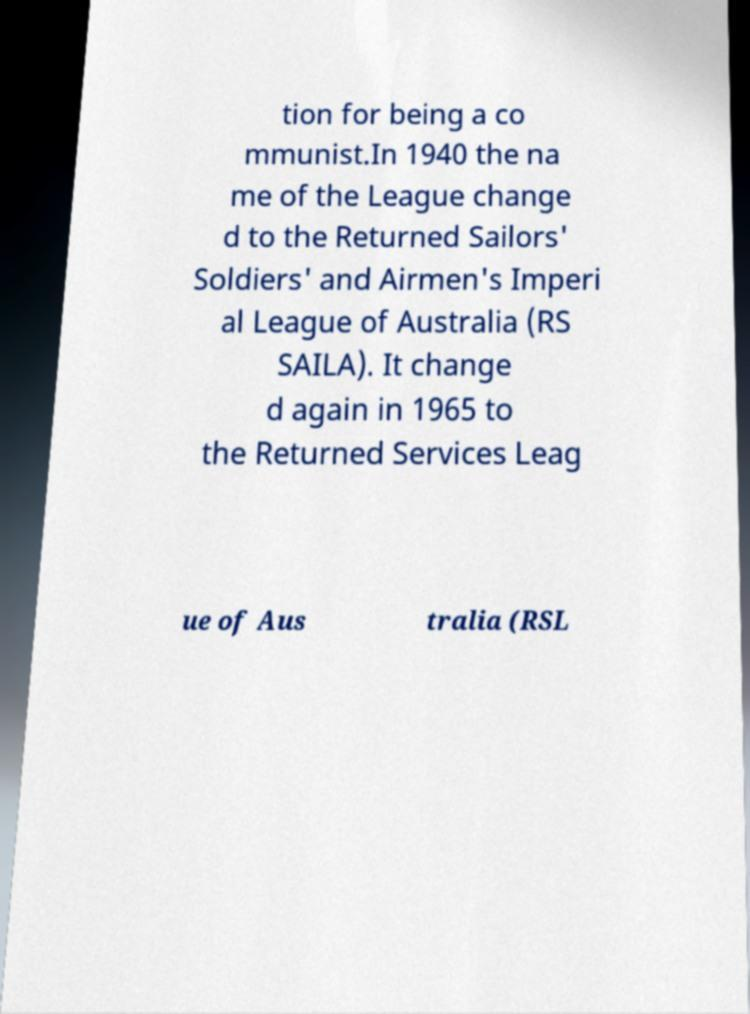Can you read and provide the text displayed in the image?This photo seems to have some interesting text. Can you extract and type it out for me? tion for being a co mmunist.In 1940 the na me of the League change d to the Returned Sailors' Soldiers' and Airmen's Imperi al League of Australia (RS SAILA). It change d again in 1965 to the Returned Services Leag ue of Aus tralia (RSL 